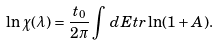<formula> <loc_0><loc_0><loc_500><loc_500>\ln \chi ( \lambda ) = \frac { t _ { 0 } } { 2 \pi } \int \, d E t r \ln ( 1 + A ) .</formula> 